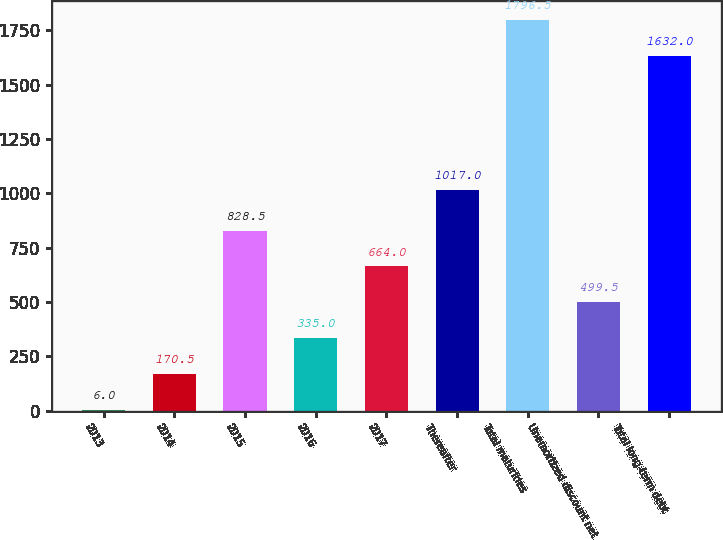<chart> <loc_0><loc_0><loc_500><loc_500><bar_chart><fcel>2013<fcel>2014<fcel>2015<fcel>2016<fcel>2017<fcel>Thereafter<fcel>Total maturities<fcel>Unamortized discount net<fcel>Total long-term debt<nl><fcel>6<fcel>170.5<fcel>828.5<fcel>335<fcel>664<fcel>1017<fcel>1796.5<fcel>499.5<fcel>1632<nl></chart> 